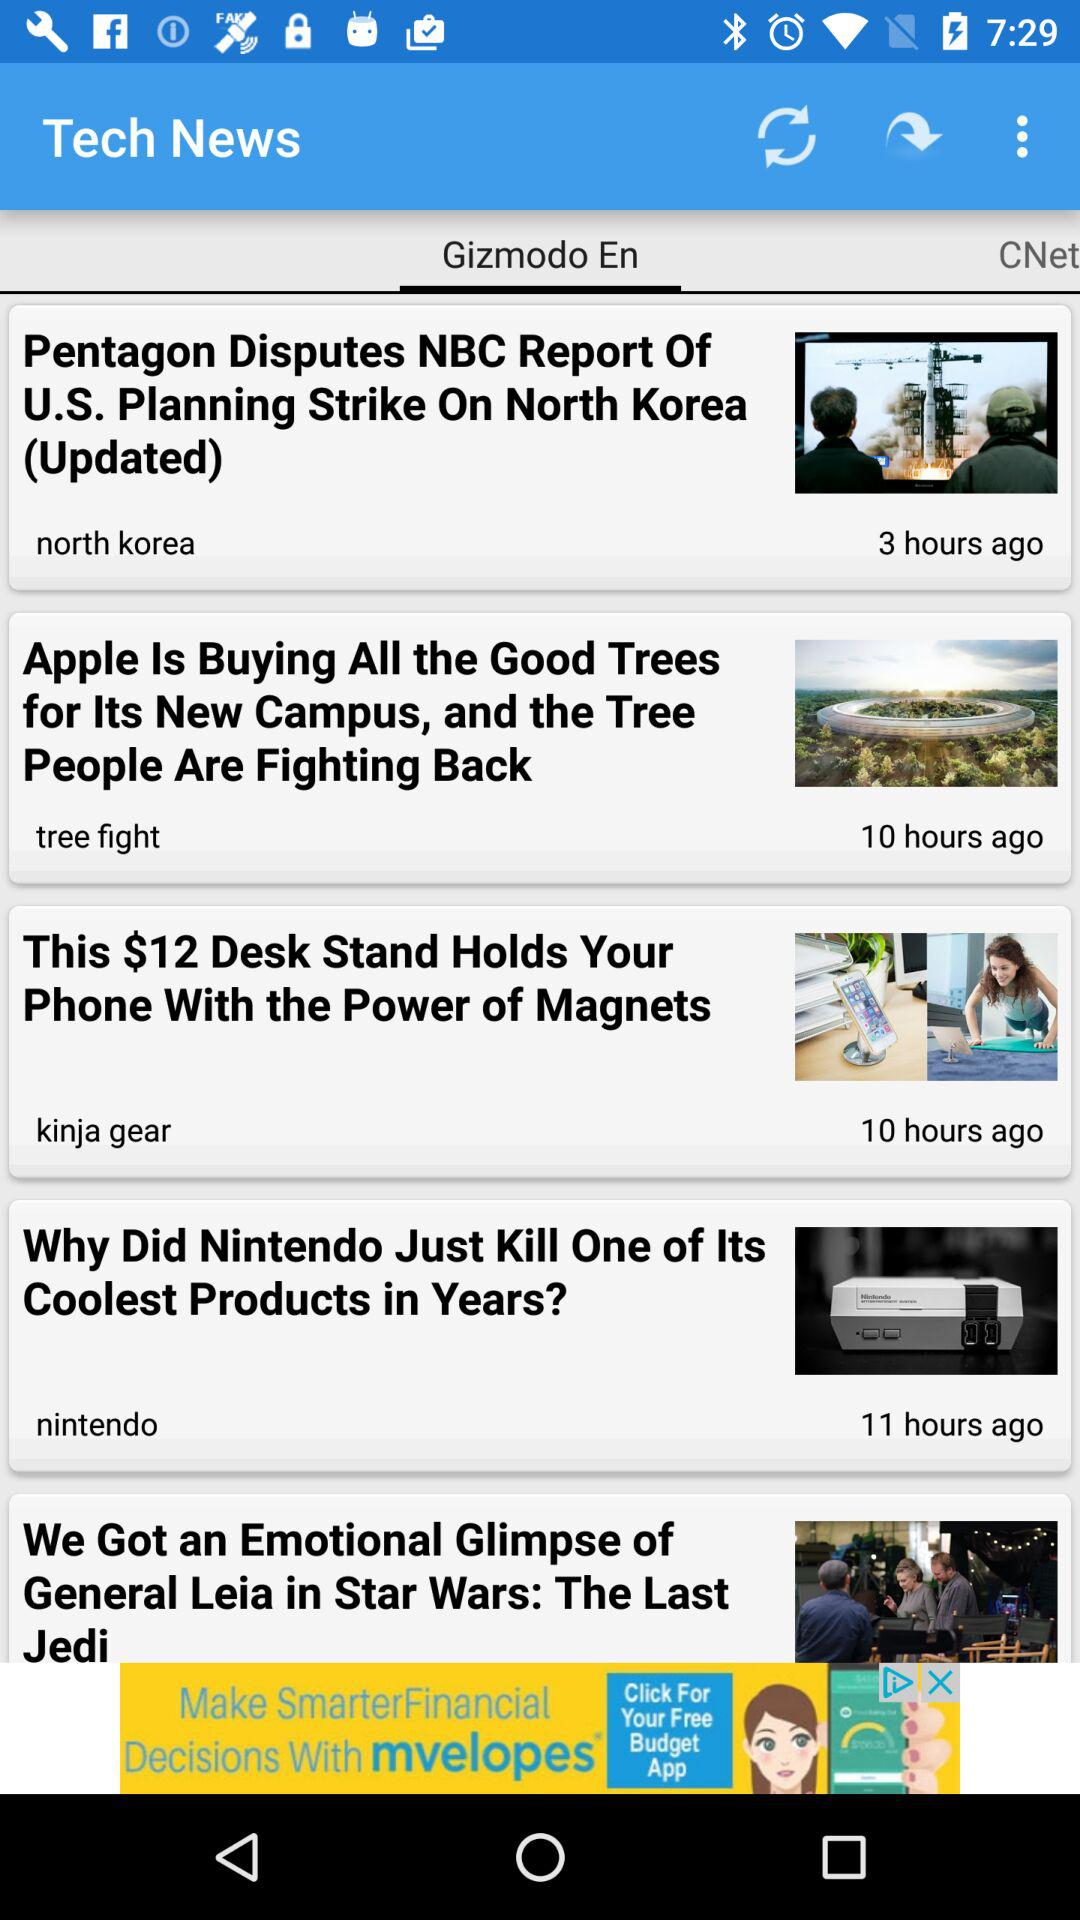When was the news of North Korea updated? The news was updated 3 hours ago. 